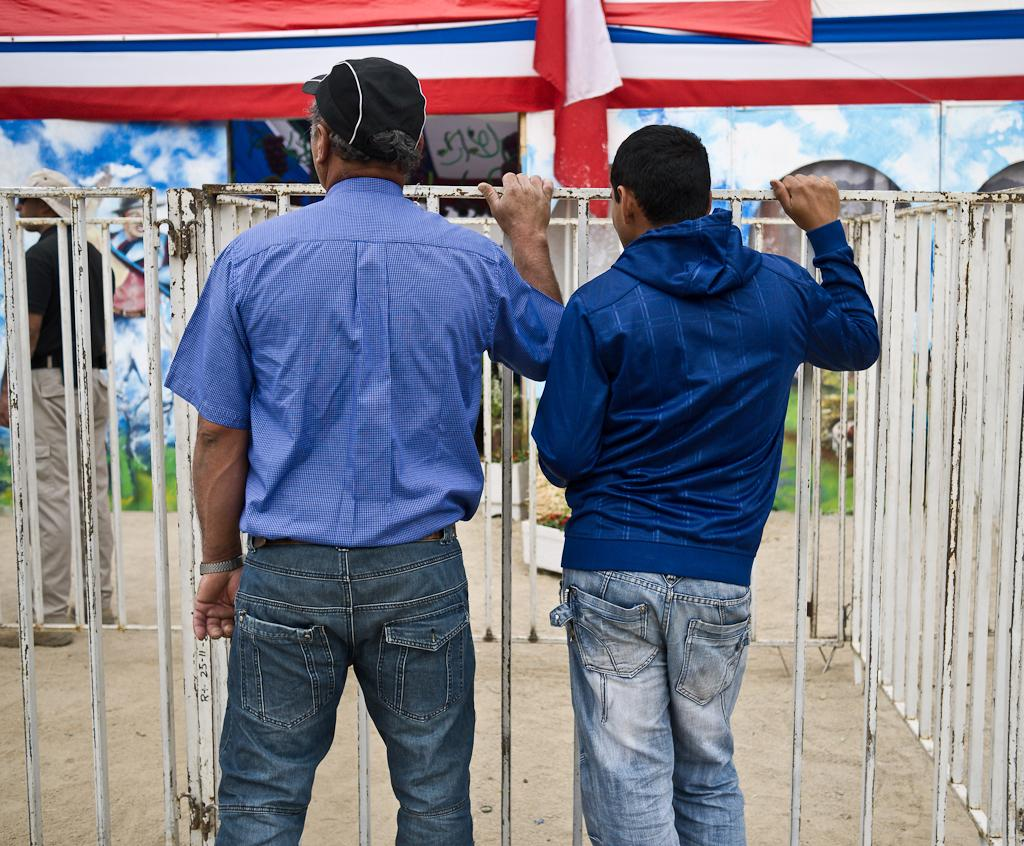What can be seen in the image involving human presence? There are people standing in the image. What object is present in the image that might be related to cooking or food preparation? There is a grille in the image. What can be seen in the background of the image that might indicate a domestic setting? There are clothes visible in the background of the image. What is visible in the background of the image that might indicate the time of day or weather conditions? The sky is visible in the background of the image. Can you hear the people in the image start jumping around? There is no sound or indication of jumping in the image; it is a still image. 